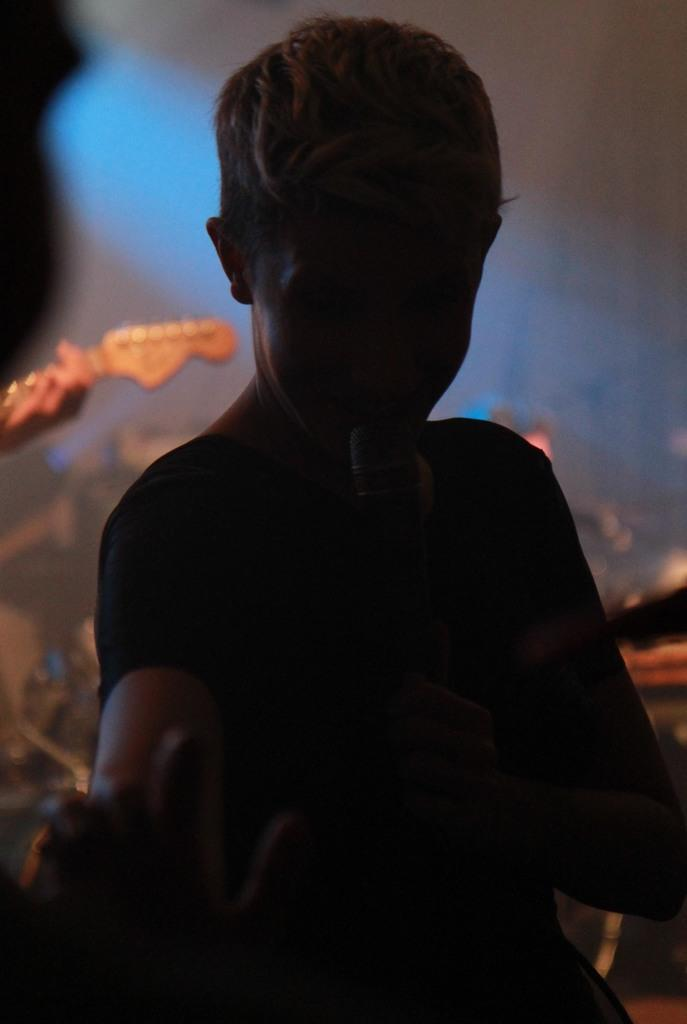What is the person in the image holding? The person in the image is holding a microphone. Can you describe the position of the person's hand in the image? There is a hand of a person visible in front of the person with the microphone. What can be seen behind the person with the microphone? There is another person behind the person with the microphone. What else is present in the image besides the people? There are musical instruments in the image. Can you tell me how many visitors are present in the image? There is no mention of visitors in the image; it features a person holding a microphone, another person behind them, and musical instruments. What type of vein can be seen in the image? There is no vein visible in the image. 